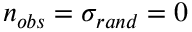<formula> <loc_0><loc_0><loc_500><loc_500>n _ { o b s } = \sigma _ { r a n d } = 0</formula> 